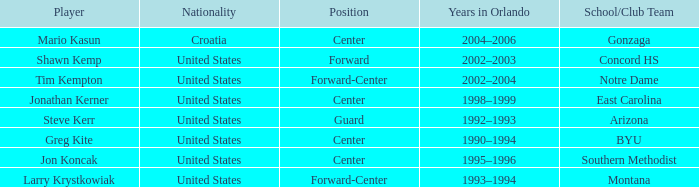Which player has montana as the school/club team? Larry Krystkowiak. 